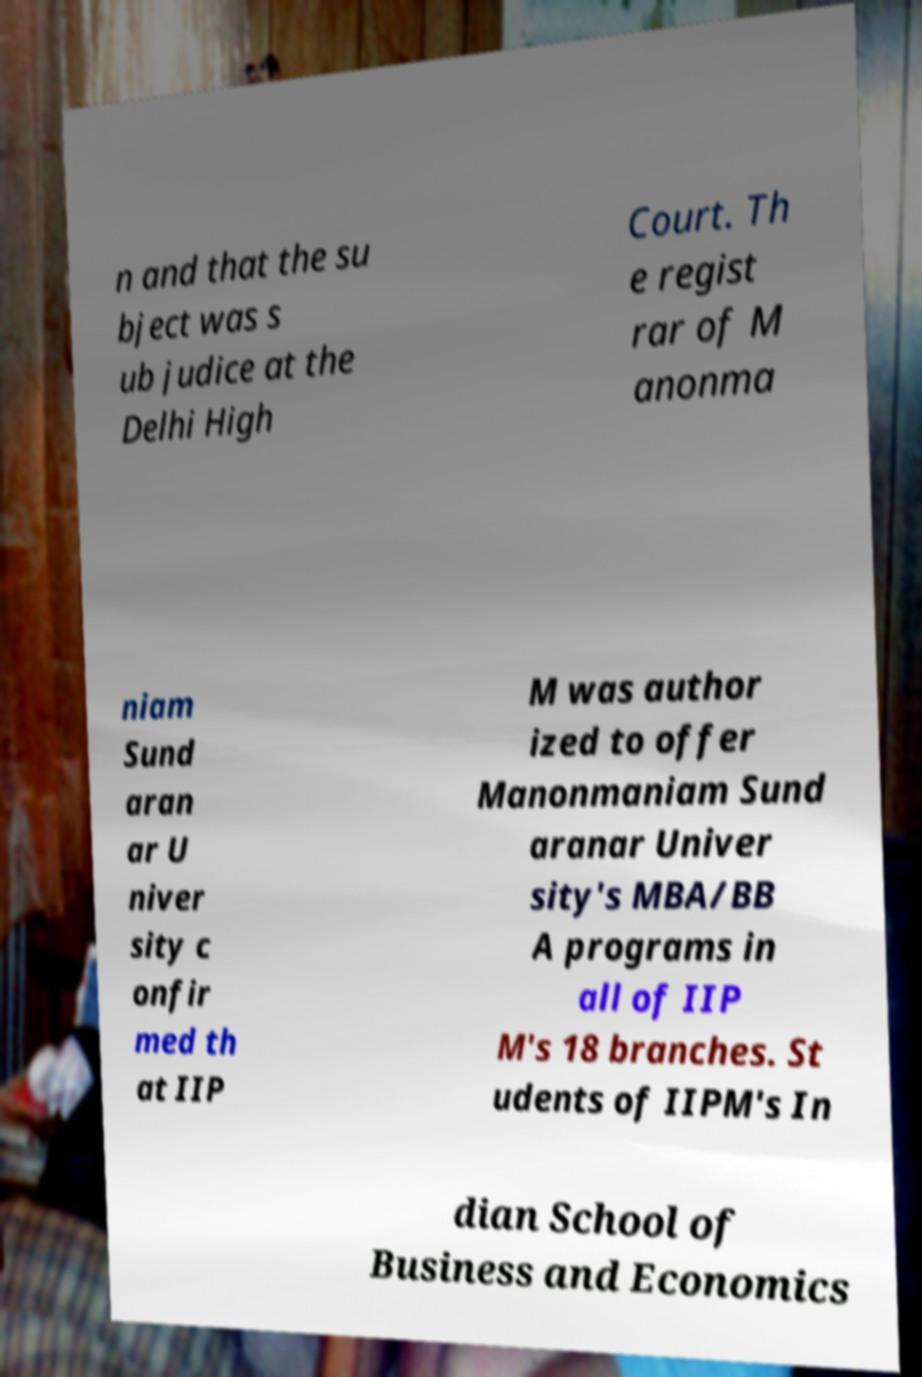Can you accurately transcribe the text from the provided image for me? n and that the su bject was s ub judice at the Delhi High Court. Th e regist rar of M anonma niam Sund aran ar U niver sity c onfir med th at IIP M was author ized to offer Manonmaniam Sund aranar Univer sity's MBA/BB A programs in all of IIP M's 18 branches. St udents of IIPM's In dian School of Business and Economics 